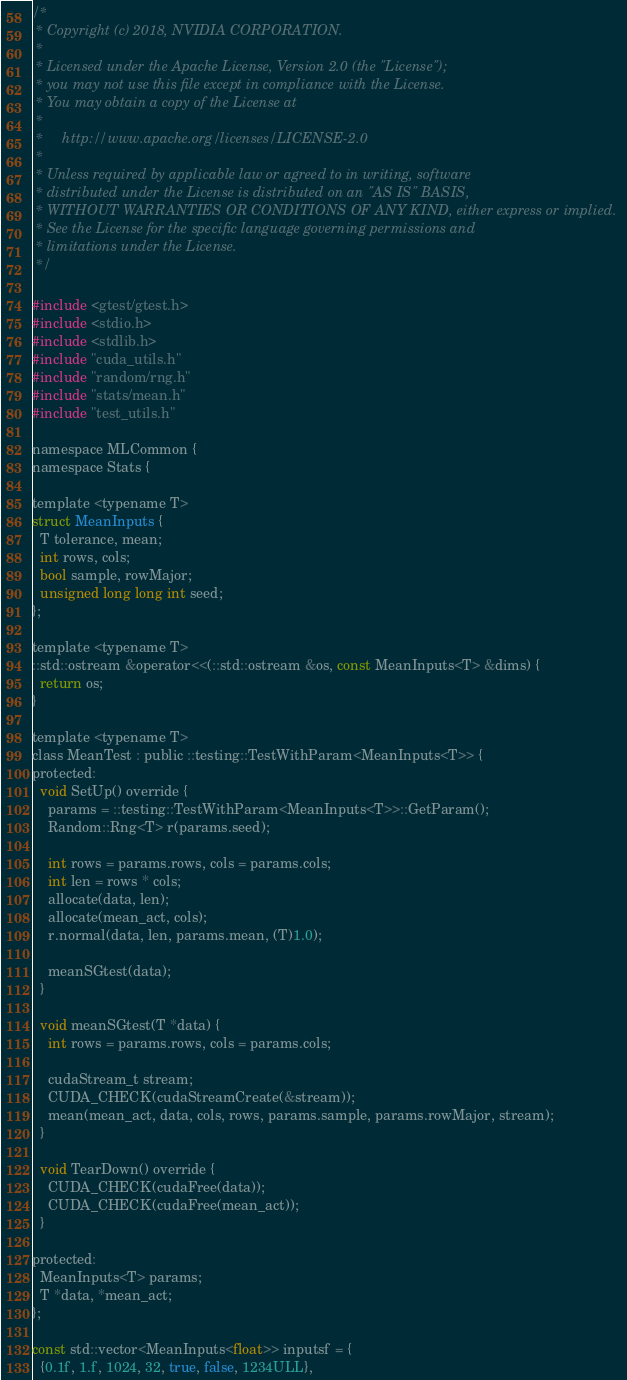Convert code to text. <code><loc_0><loc_0><loc_500><loc_500><_Cuda_>/*
 * Copyright (c) 2018, NVIDIA CORPORATION.
 *
 * Licensed under the Apache License, Version 2.0 (the "License");
 * you may not use this file except in compliance with the License.
 * You may obtain a copy of the License at
 *
 *     http://www.apache.org/licenses/LICENSE-2.0
 *
 * Unless required by applicable law or agreed to in writing, software
 * distributed under the License is distributed on an "AS IS" BASIS,
 * WITHOUT WARRANTIES OR CONDITIONS OF ANY KIND, either express or implied.
 * See the License for the specific language governing permissions and
 * limitations under the License.
 */

#include <gtest/gtest.h>
#include <stdio.h>
#include <stdlib.h>
#include "cuda_utils.h"
#include "random/rng.h"
#include "stats/mean.h"
#include "test_utils.h"

namespace MLCommon {
namespace Stats {

template <typename T>
struct MeanInputs {
  T tolerance, mean;
  int rows, cols;
  bool sample, rowMajor;
  unsigned long long int seed;
};

template <typename T>
::std::ostream &operator<<(::std::ostream &os, const MeanInputs<T> &dims) {
  return os;
}

template <typename T>
class MeanTest : public ::testing::TestWithParam<MeanInputs<T>> {
protected:
  void SetUp() override {
    params = ::testing::TestWithParam<MeanInputs<T>>::GetParam();
    Random::Rng<T> r(params.seed);

    int rows = params.rows, cols = params.cols;
    int len = rows * cols;
    allocate(data, len);
    allocate(mean_act, cols);
    r.normal(data, len, params.mean, (T)1.0);

    meanSGtest(data);
  }

  void meanSGtest(T *data) {
    int rows = params.rows, cols = params.cols;

    cudaStream_t stream;
    CUDA_CHECK(cudaStreamCreate(&stream));
    mean(mean_act, data, cols, rows, params.sample, params.rowMajor, stream);
  }

  void TearDown() override {
    CUDA_CHECK(cudaFree(data));
    CUDA_CHECK(cudaFree(mean_act));
  }

protected:
  MeanInputs<T> params;
  T *data, *mean_act;
};

const std::vector<MeanInputs<float>> inputsf = {
  {0.1f, 1.f, 1024, 32, true, false, 1234ULL},</code> 